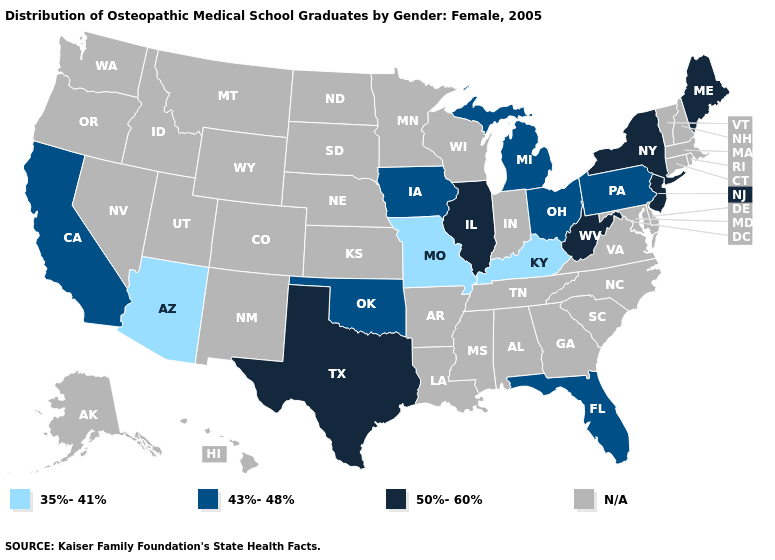Name the states that have a value in the range 35%-41%?
Answer briefly. Arizona, Kentucky, Missouri. What is the value of Alaska?
Give a very brief answer. N/A. Name the states that have a value in the range N/A?
Concise answer only. Alabama, Alaska, Arkansas, Colorado, Connecticut, Delaware, Georgia, Hawaii, Idaho, Indiana, Kansas, Louisiana, Maryland, Massachusetts, Minnesota, Mississippi, Montana, Nebraska, Nevada, New Hampshire, New Mexico, North Carolina, North Dakota, Oregon, Rhode Island, South Carolina, South Dakota, Tennessee, Utah, Vermont, Virginia, Washington, Wisconsin, Wyoming. Name the states that have a value in the range 43%-48%?
Quick response, please. California, Florida, Iowa, Michigan, Ohio, Oklahoma, Pennsylvania. Name the states that have a value in the range N/A?
Write a very short answer. Alabama, Alaska, Arkansas, Colorado, Connecticut, Delaware, Georgia, Hawaii, Idaho, Indiana, Kansas, Louisiana, Maryland, Massachusetts, Minnesota, Mississippi, Montana, Nebraska, Nevada, New Hampshire, New Mexico, North Carolina, North Dakota, Oregon, Rhode Island, South Carolina, South Dakota, Tennessee, Utah, Vermont, Virginia, Washington, Wisconsin, Wyoming. Does the first symbol in the legend represent the smallest category?
Give a very brief answer. Yes. Which states have the lowest value in the MidWest?
Concise answer only. Missouri. What is the value of Wisconsin?
Keep it brief. N/A. What is the highest value in the USA?
Quick response, please. 50%-60%. Which states have the lowest value in the USA?
Concise answer only. Arizona, Kentucky, Missouri. Which states have the lowest value in the USA?
Answer briefly. Arizona, Kentucky, Missouri. Among the states that border Maryland , which have the lowest value?
Concise answer only. Pennsylvania. Name the states that have a value in the range 50%-60%?
Be succinct. Illinois, Maine, New Jersey, New York, Texas, West Virginia. What is the lowest value in states that border California?
Keep it brief. 35%-41%. What is the value of Illinois?
Give a very brief answer. 50%-60%. 